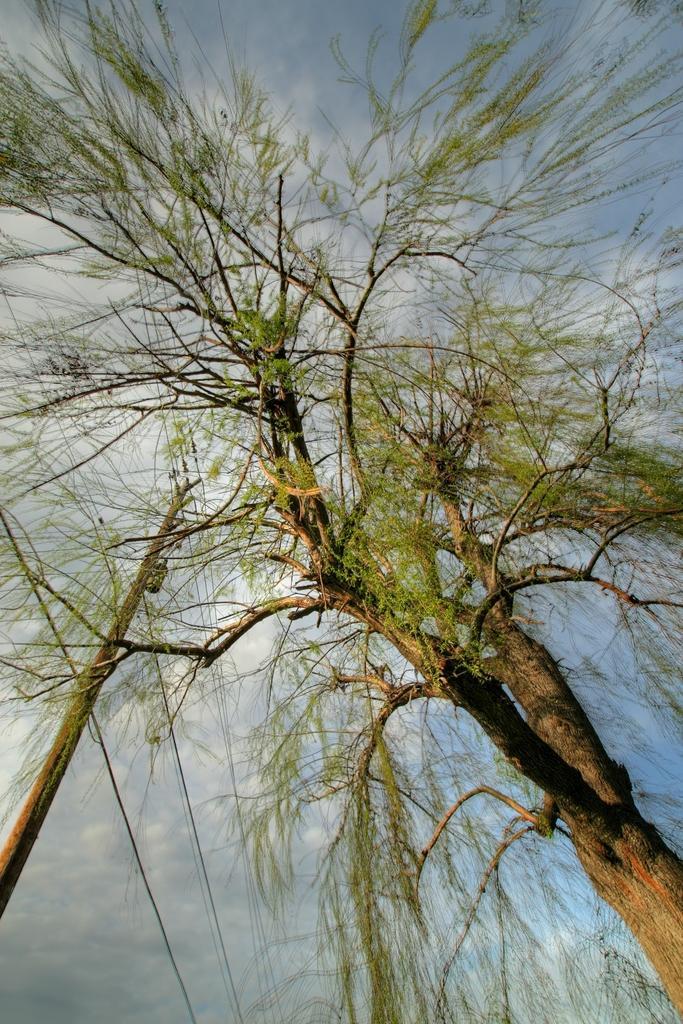Please provide a concise description of this image. In this image I can see a tree and a pole. In the background I can see the sky. 